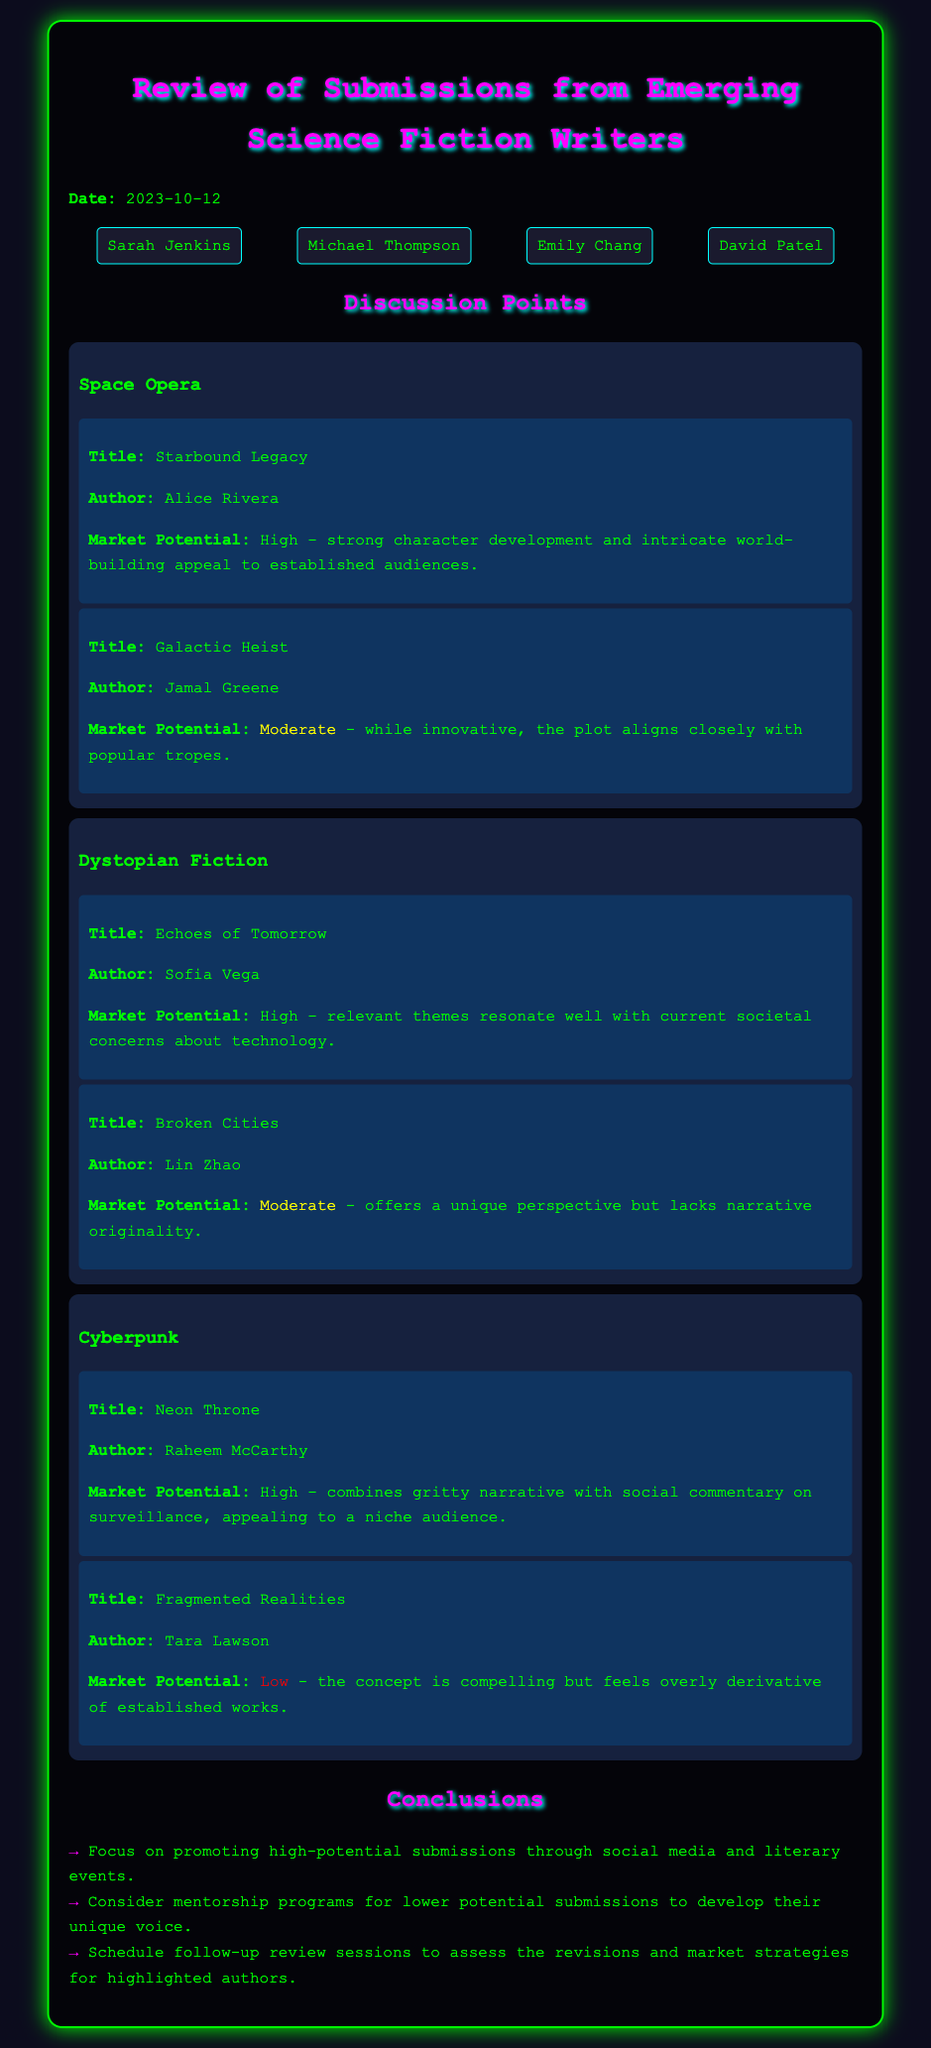what is the date of the meeting? The date is mentioned at the beginning of the document as "2023-10-12".
Answer: 2023-10-12 who is the author of "Starbound Legacy"? The author of this submission is listed in the document under its description.
Answer: Alice Rivera what is the market potential of "Echoes of Tomorrow"? The document specifies the market potential of this title directly.
Answer: High which genre does "Fragmented Realities" belong to? The genre is indicated in the section where the submission is categorized.
Answer: Cyberpunk how many attendees are listed in the meeting minutes? The number of attendees is provided at the beginning in a dedicated section.
Answer: 4 which submission has the lowest market potential? The document indicates the market potential levels for each submission, allowing for identification of the lowest one.
Answer: Fragmented Realities what conclusion involves mentorship programs? The conclusion section outlines several strategies regarding submissions, including this one.
Answer: Consider mentorship programs for lower potential submissions to develop their unique voice who discussed the "Galactic Heist"? The document does not specify who discussed it but lists it as part of the submissions considered.
Answer: Not specified 